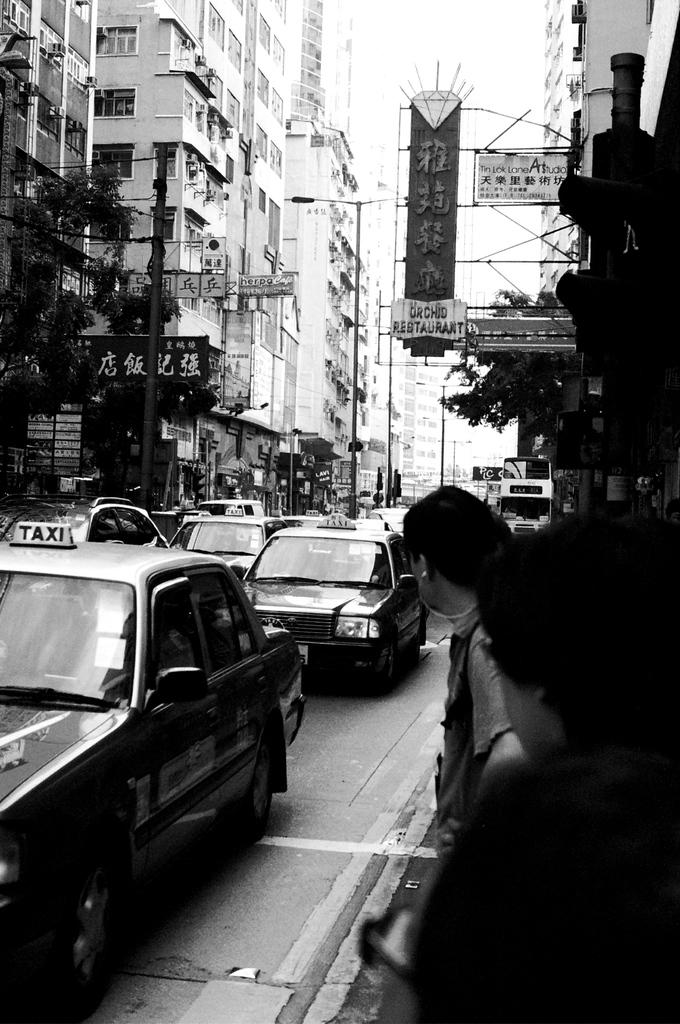Is there a taxi?
Your answer should be very brief. Yes. What kind of vehicle is the first car shown in the picture?
Your response must be concise. Taxi. 